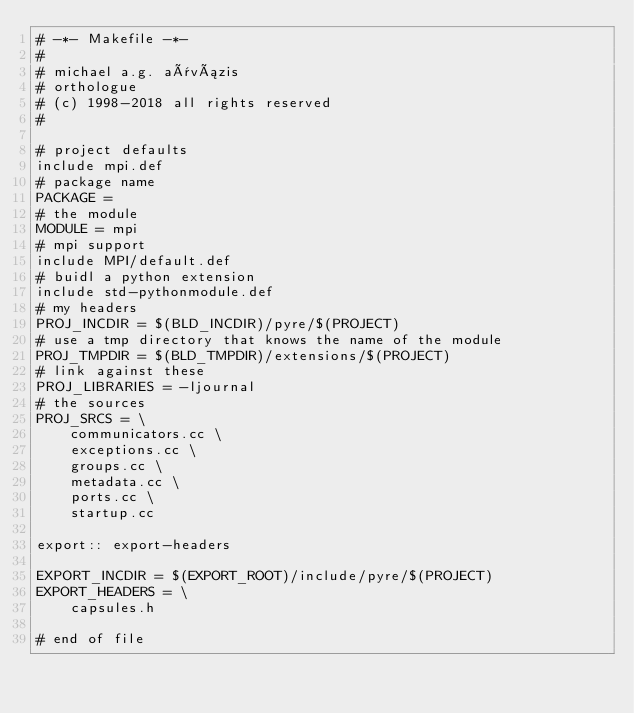<code> <loc_0><loc_0><loc_500><loc_500><_ObjectiveC_># -*- Makefile -*-
#
# michael a.g. aïvázis
# orthologue
# (c) 1998-2018 all rights reserved
#

# project defaults
include mpi.def
# package name
PACKAGE =
# the module
MODULE = mpi
# mpi support
include MPI/default.def
# buidl a python extension
include std-pythonmodule.def
# my headers
PROJ_INCDIR = $(BLD_INCDIR)/pyre/$(PROJECT)
# use a tmp directory that knows the name of the module
PROJ_TMPDIR = $(BLD_TMPDIR)/extensions/$(PROJECT)
# link against these
PROJ_LIBRARIES = -ljournal
# the sources
PROJ_SRCS = \
    communicators.cc \
    exceptions.cc \
    groups.cc \
    metadata.cc \
    ports.cc \
    startup.cc

export:: export-headers

EXPORT_INCDIR = $(EXPORT_ROOT)/include/pyre/$(PROJECT)
EXPORT_HEADERS = \
    capsules.h

# end of file
</code> 